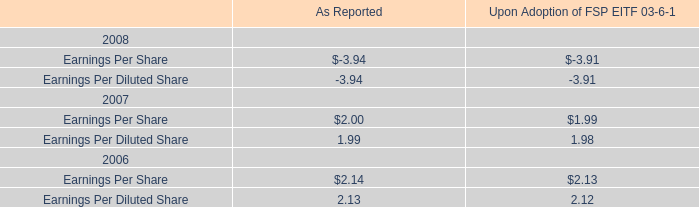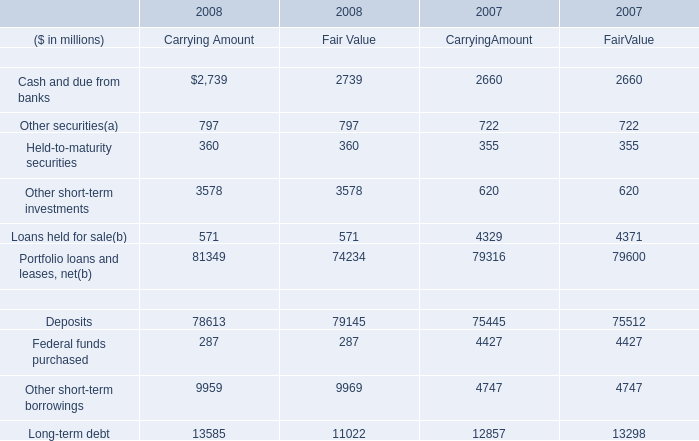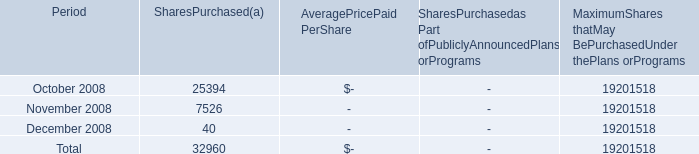What was the sum of Held-to-maturity securities without those Held-to-maturity securities smaller than 355? (in million) 
Computations: (((355 + 355) + 360) + 360)
Answer: 1430.0. 